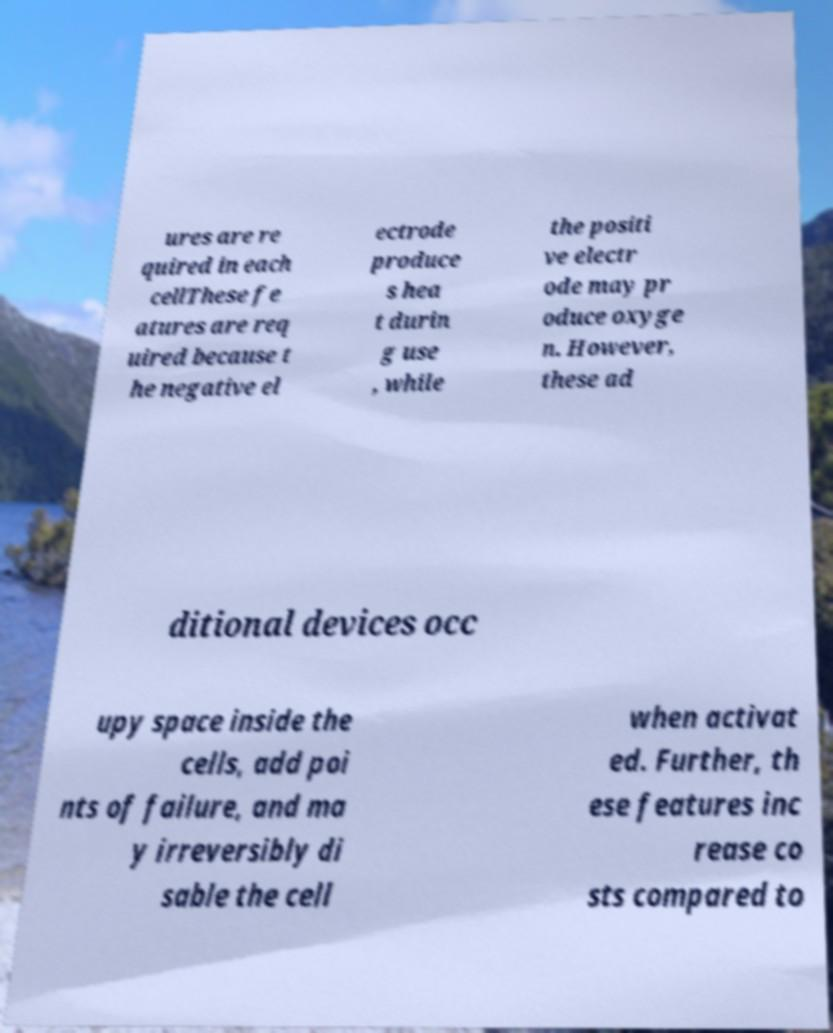For documentation purposes, I need the text within this image transcribed. Could you provide that? ures are re quired in each cellThese fe atures are req uired because t he negative el ectrode produce s hea t durin g use , while the positi ve electr ode may pr oduce oxyge n. However, these ad ditional devices occ upy space inside the cells, add poi nts of failure, and ma y irreversibly di sable the cell when activat ed. Further, th ese features inc rease co sts compared to 